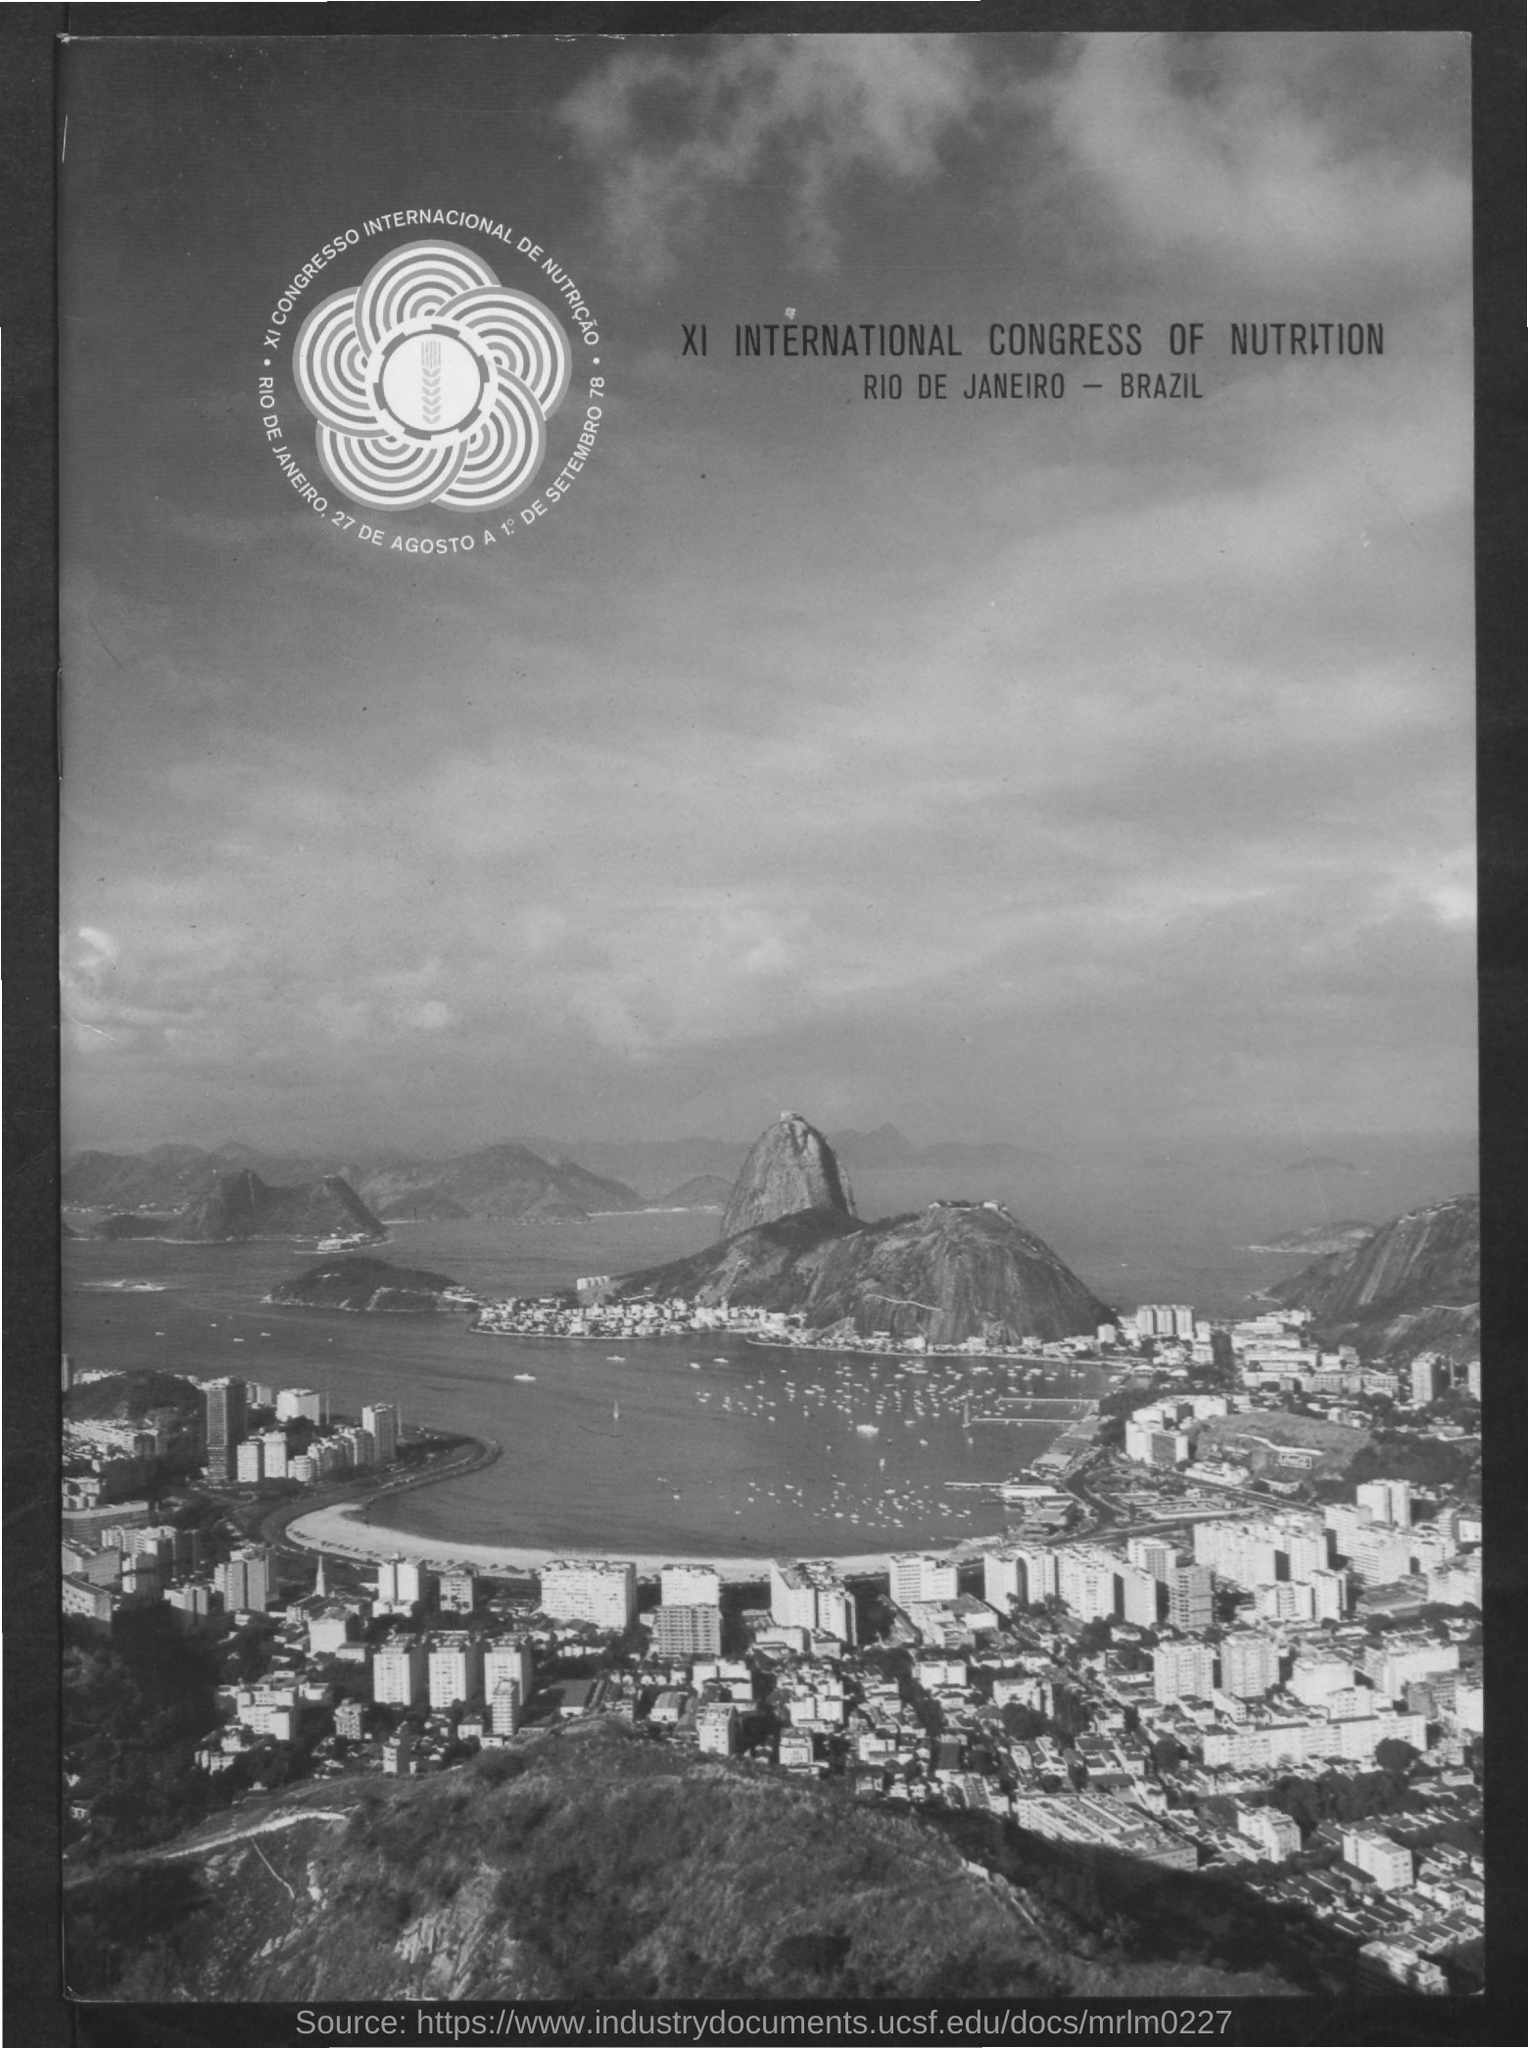What is the program name?
Provide a short and direct response. XI INTERNATIONAL CONGRESS OF NUTRITION. Where is the congress going to be held?
Provide a succinct answer. RIO DE JANEIRO- BRAZIL. 